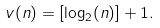Convert formula to latex. <formula><loc_0><loc_0><loc_500><loc_500>v ( n ) = [ \log _ { 2 } ( n ) ] + 1 .</formula> 